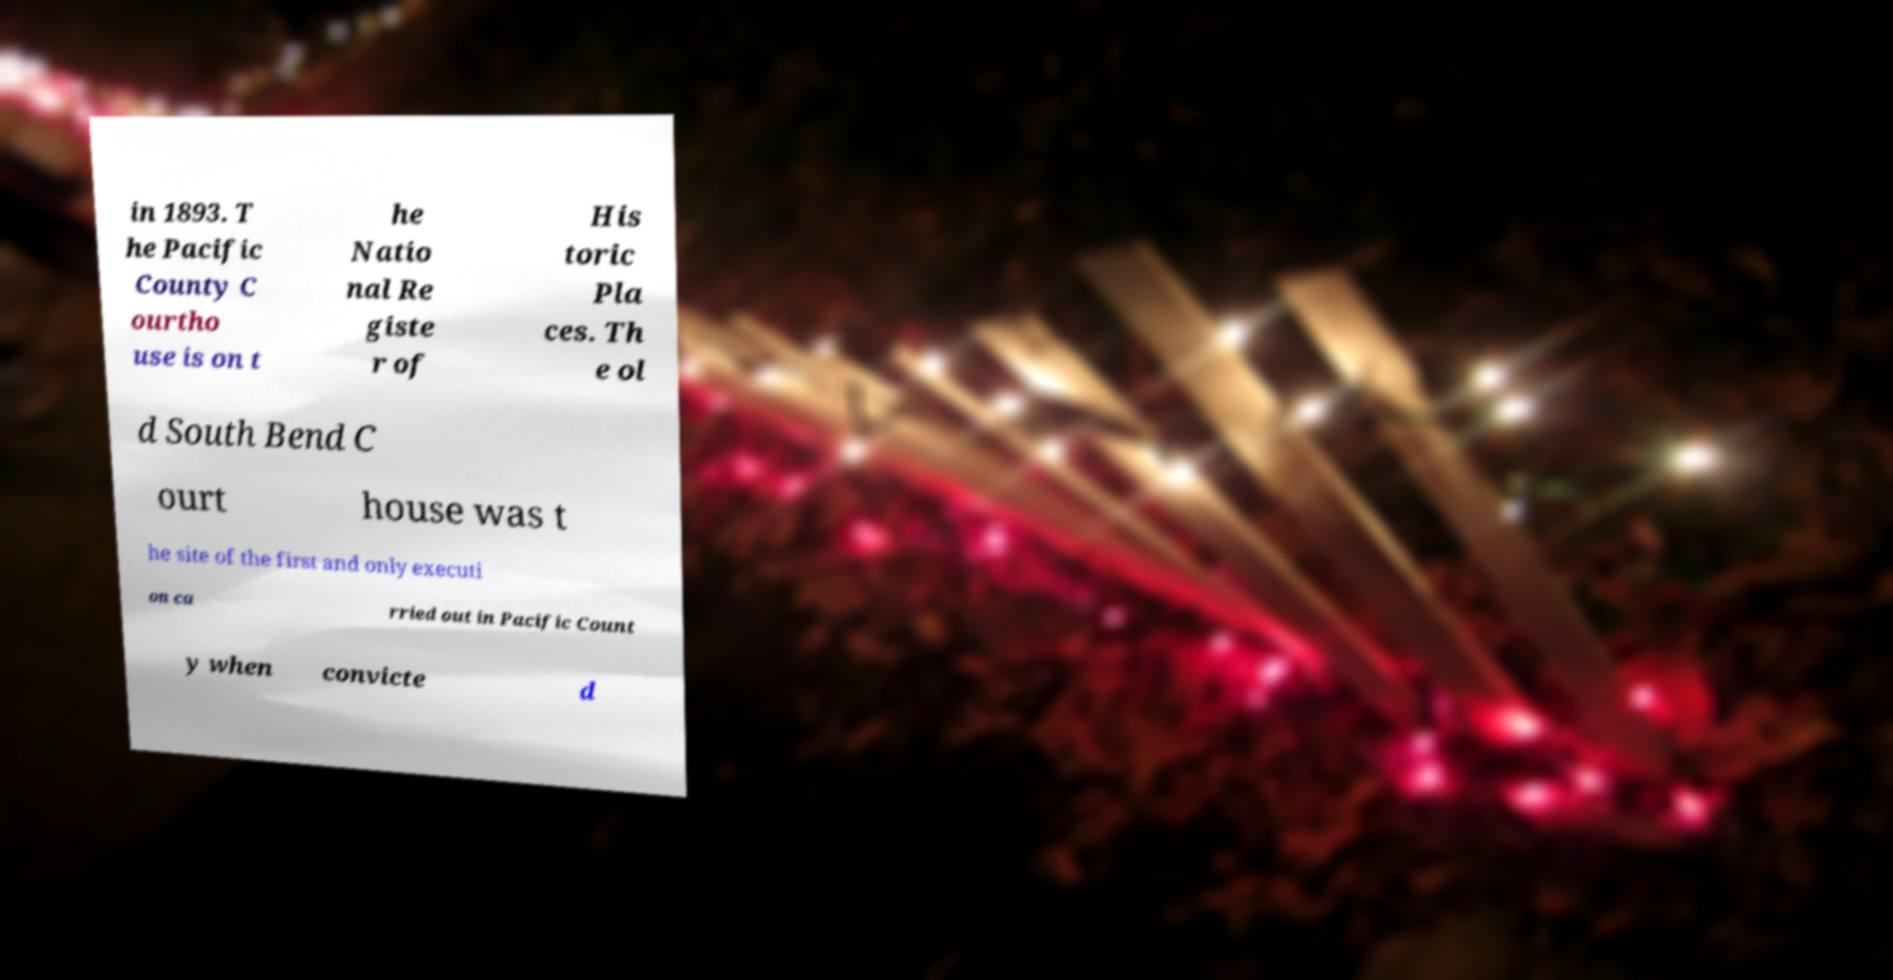Please identify and transcribe the text found in this image. in 1893. T he Pacific County C ourtho use is on t he Natio nal Re giste r of His toric Pla ces. Th e ol d South Bend C ourt house was t he site of the first and only executi on ca rried out in Pacific Count y when convicte d 